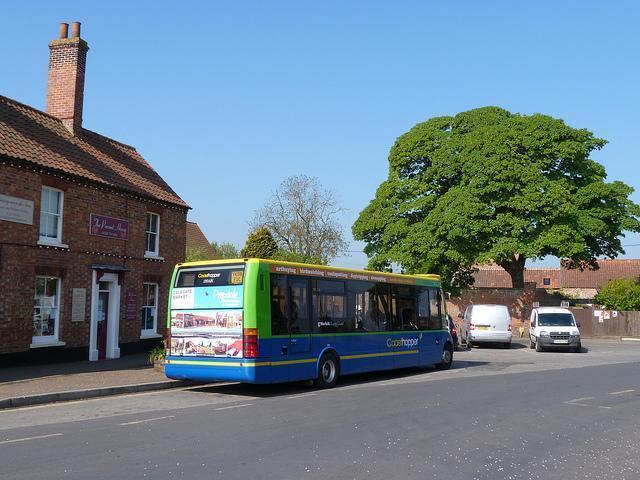How many legs are on the sheep above?
Give a very brief answer. 0. 